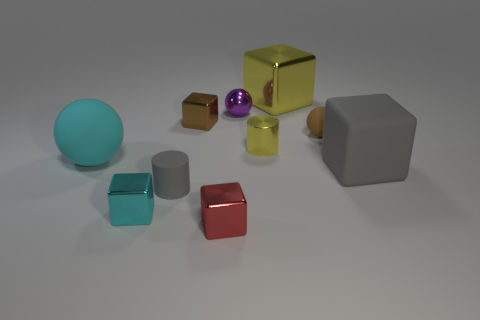What number of small cyan objects are the same shape as the large gray thing?
Keep it short and to the point. 1. Are there an equal number of small matte objects that are right of the brown matte sphere and tiny brown spheres that are behind the tiny brown cube?
Your answer should be compact. Yes. Is there a small purple rubber block?
Ensure brevity in your answer.  No. There is a gray thing that is right of the brown shiny cube behind the matte thing left of the small matte cylinder; what is its size?
Provide a short and direct response. Large. The brown matte thing that is the same size as the brown metal object is what shape?
Make the answer very short. Sphere. Is there anything else that is the same material as the cyan block?
Make the answer very short. Yes. What number of objects are either rubber spheres to the left of the yellow cylinder or small yellow metallic things?
Your answer should be very brief. 2. There is a large cube that is on the right side of the big block that is behind the large gray object; are there any tiny yellow cylinders that are to the left of it?
Make the answer very short. Yes. How many small yellow metallic things are there?
Provide a short and direct response. 1. What number of things are cubes that are on the left side of the purple shiny thing or tiny metallic things that are in front of the small brown rubber object?
Ensure brevity in your answer.  4. 